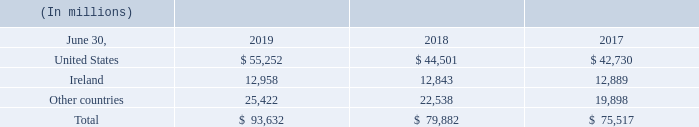Assets are not allocated to segments for internal reporting presentations. A portion of amortization and depreciation is included with various other costs in an overhead allocation to each segment; it is impracticable for us to separately identify the amount of amortization and depreciation by segment that is included in the measure of segment profit or loss.
Long-lived assets, excluding financial instruments and tax assets, classified by the location of the controlling statutory company and with countries over 10% of the total shown separately, were as follows:
What reason does the company give for not separately identifying the amount of amortization and depreciation by segment? It is impracticable for us to separately identify the amount of amortization and depreciation by segment that is included in the measure of segment profit or loss. How is the portion of amortization and depreciation allocated? A portion of amortization and depreciation is included with various other costs in an overhead allocation to each segment. How many countries have Long-lived assets, excluding financial instruments and tax assets, classified by the location of the controlling statutory company and with countriesover 10% of the total assets? United States##Ireland
Answer: 2. How many millions of long-lived assets were there in the United States in 2019?
Answer scale should be: million. 55,252. What was the percentage change in the total long-lived assets from 2017 to 2018?
Answer scale should be: percent. (79,882-75,517)/75,517
Answer: 5.78. How many years during 2017 to 2019 did the long-lived asset amount in Ireland exceed $12,900 million? 12,958
Answer: 1. 